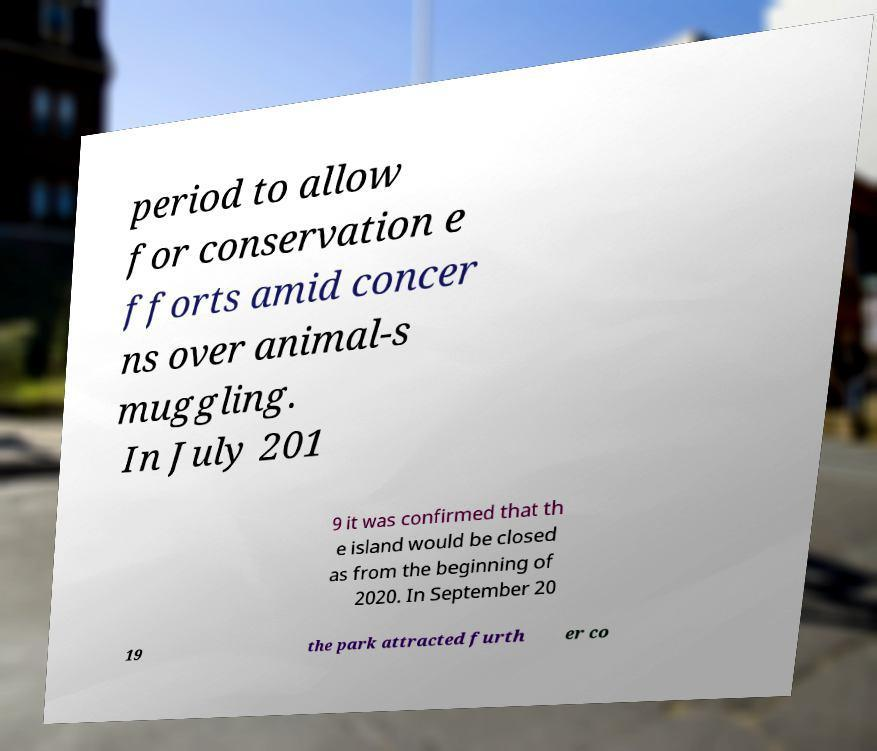Could you assist in decoding the text presented in this image and type it out clearly? period to allow for conservation e fforts amid concer ns over animal-s muggling. In July 201 9 it was confirmed that th e island would be closed as from the beginning of 2020. In September 20 19 the park attracted furth er co 